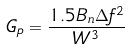Convert formula to latex. <formula><loc_0><loc_0><loc_500><loc_500>G _ { p } = \frac { 1 . 5 B _ { n } \Delta f ^ { 2 } } { W ^ { 3 } }</formula> 